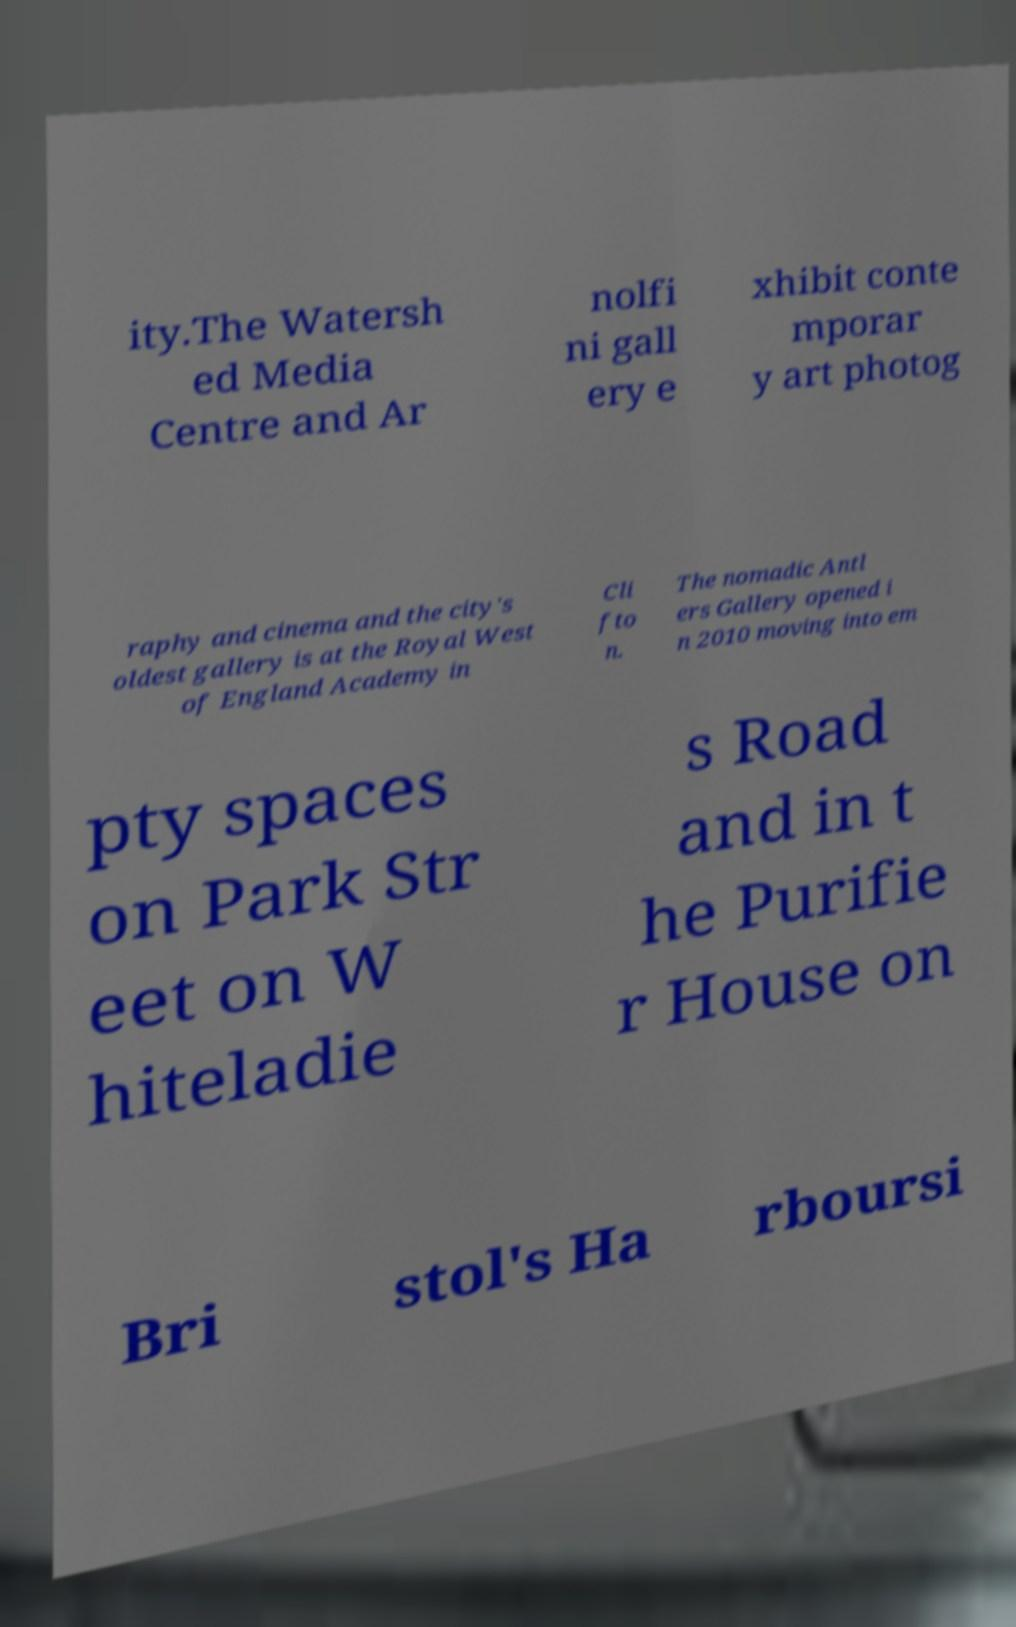Can you accurately transcribe the text from the provided image for me? ity.The Watersh ed Media Centre and Ar nolfi ni gall ery e xhibit conte mporar y art photog raphy and cinema and the city's oldest gallery is at the Royal West of England Academy in Cli fto n. The nomadic Antl ers Gallery opened i n 2010 moving into em pty spaces on Park Str eet on W hiteladie s Road and in t he Purifie r House on Bri stol's Ha rboursi 